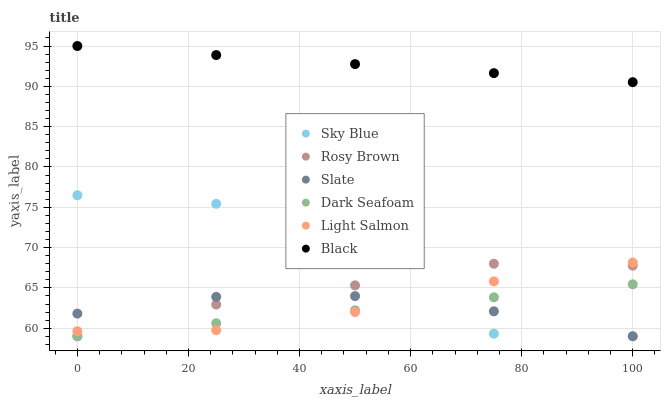Does Dark Seafoam have the minimum area under the curve?
Answer yes or no. Yes. Does Black have the maximum area under the curve?
Answer yes or no. Yes. Does Slate have the minimum area under the curve?
Answer yes or no. No. Does Slate have the maximum area under the curve?
Answer yes or no. No. Is Dark Seafoam the smoothest?
Answer yes or no. Yes. Is Sky Blue the roughest?
Answer yes or no. Yes. Is Slate the smoothest?
Answer yes or no. No. Is Slate the roughest?
Answer yes or no. No. Does Slate have the lowest value?
Answer yes or no. Yes. Does Black have the lowest value?
Answer yes or no. No. Does Black have the highest value?
Answer yes or no. Yes. Does Rosy Brown have the highest value?
Answer yes or no. No. Is Sky Blue less than Black?
Answer yes or no. Yes. Is Black greater than Light Salmon?
Answer yes or no. Yes. Does Light Salmon intersect Dark Seafoam?
Answer yes or no. Yes. Is Light Salmon less than Dark Seafoam?
Answer yes or no. No. Is Light Salmon greater than Dark Seafoam?
Answer yes or no. No. Does Sky Blue intersect Black?
Answer yes or no. No. 